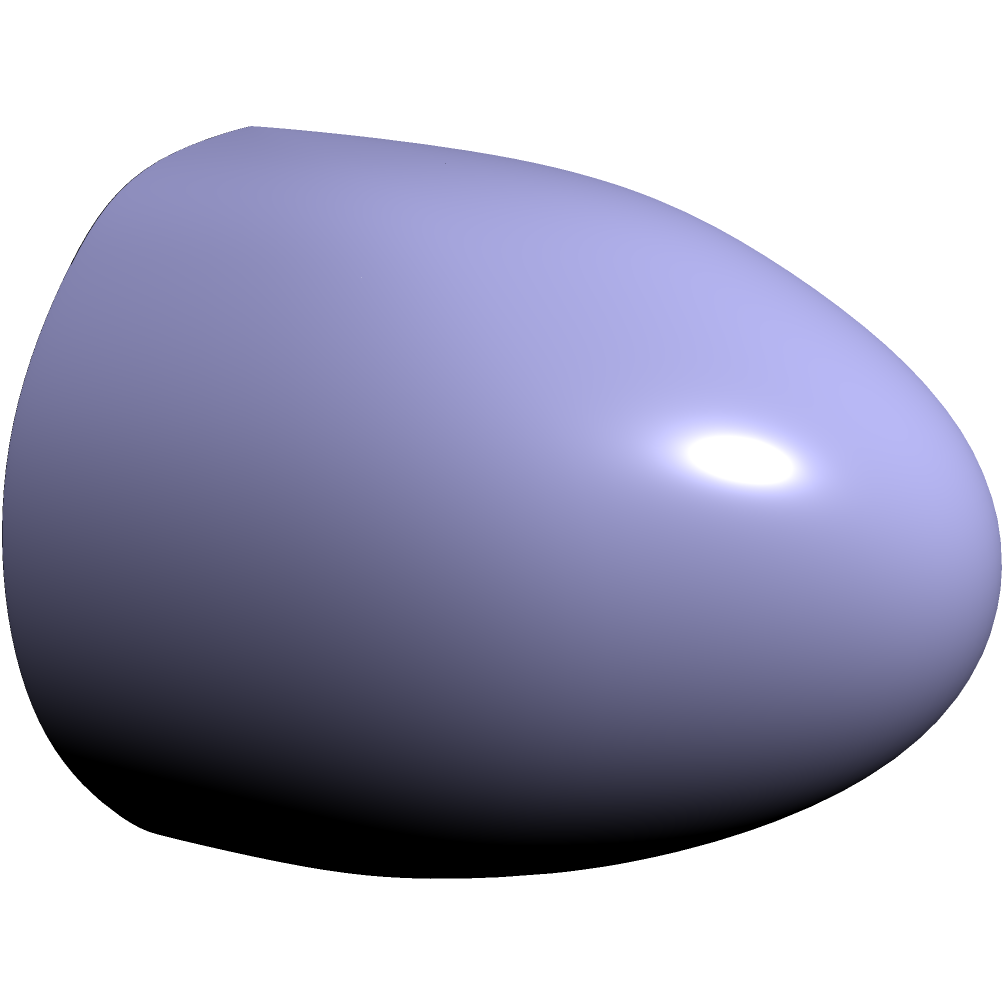On a perfectly spherical football with a radius of 2 units, you need to throw the ball from point A (0,2,0) to point B (0,-2,0). What is the length of the shortest path between these two points on the surface of the football? To find the shortest path between two points on a sphere, we need to calculate the length of the great circle arc connecting them. Here's how we can solve this:

1) First, we need to find the angle between the two points from the center of the sphere. We can do this using the dot product formula:

   $$\cos \theta = \frac{\vec{A} \cdot \vec{B}}{|\vec{A}||\vec{B}|}$$

2) In this case:
   $\vec{A} = (0,2,0)$ and $\vec{B} = (0,-2,0)$
   $\vec{A} \cdot \vec{B} = 0 \cdot 0 + 2 \cdot (-2) + 0 \cdot 0 = -4$
   $|\vec{A}| = |\vec{B}| = 2$

3) Plugging these into the formula:

   $$\cos \theta = \frac{-4}{2 \cdot 2} = -1$$

4) Taking the inverse cosine (arccos) of both sides:

   $$\theta = \arccos(-1) = \pi$$

5) Now that we have the angle, we can calculate the length of the arc. The formula for arc length is:

   $$s = r\theta$$

   where $r$ is the radius and $\theta$ is in radians.

6) Plugging in our values:

   $$s = 2\pi = 2\pi$$

Therefore, the length of the shortest path on the surface of the football is $2\pi$ units.
Answer: $2\pi$ units 